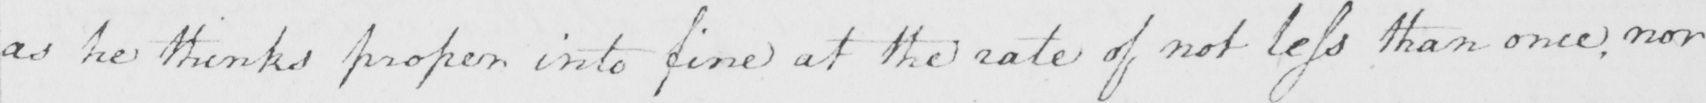What does this handwritten line say? as he thinks proper into fine at the rate of not less than once , nor 